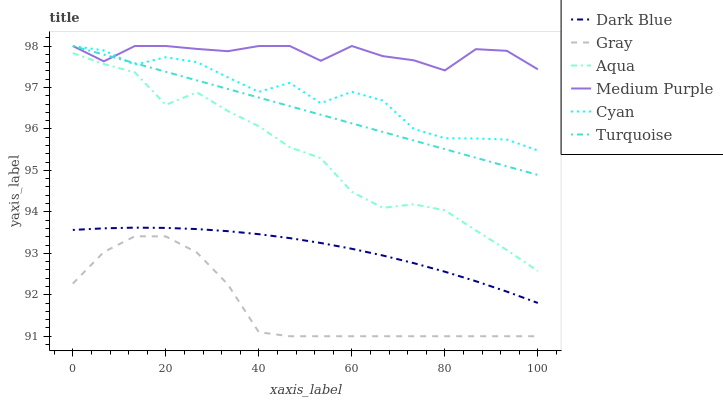Does Gray have the minimum area under the curve?
Answer yes or no. Yes. Does Medium Purple have the maximum area under the curve?
Answer yes or no. Yes. Does Turquoise have the minimum area under the curve?
Answer yes or no. No. Does Turquoise have the maximum area under the curve?
Answer yes or no. No. Is Turquoise the smoothest?
Answer yes or no. Yes. Is Cyan the roughest?
Answer yes or no. Yes. Is Aqua the smoothest?
Answer yes or no. No. Is Aqua the roughest?
Answer yes or no. No. Does Gray have the lowest value?
Answer yes or no. Yes. Does Turquoise have the lowest value?
Answer yes or no. No. Does Cyan have the highest value?
Answer yes or no. Yes. Does Aqua have the highest value?
Answer yes or no. No. Is Dark Blue less than Aqua?
Answer yes or no. Yes. Is Cyan greater than Aqua?
Answer yes or no. Yes. Does Turquoise intersect Medium Purple?
Answer yes or no. Yes. Is Turquoise less than Medium Purple?
Answer yes or no. No. Is Turquoise greater than Medium Purple?
Answer yes or no. No. Does Dark Blue intersect Aqua?
Answer yes or no. No. 